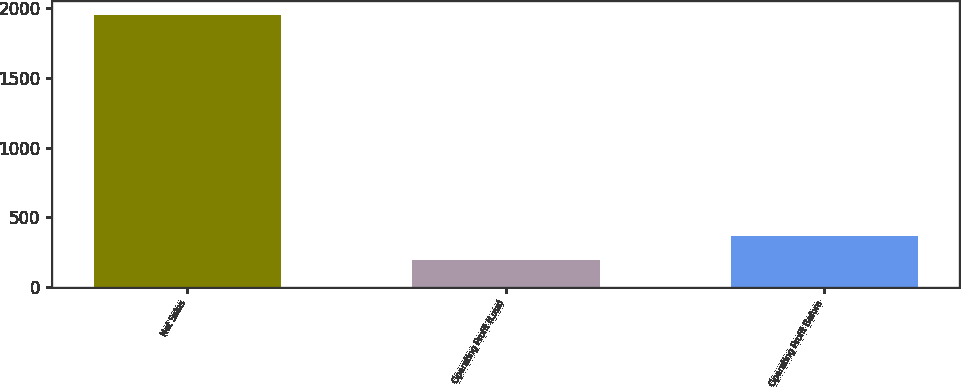Convert chart. <chart><loc_0><loc_0><loc_500><loc_500><bar_chart><fcel>Net Sales<fcel>Operating Profit (Loss)<fcel>Operating Profit Before<nl><fcel>1955<fcel>191<fcel>367.4<nl></chart> 